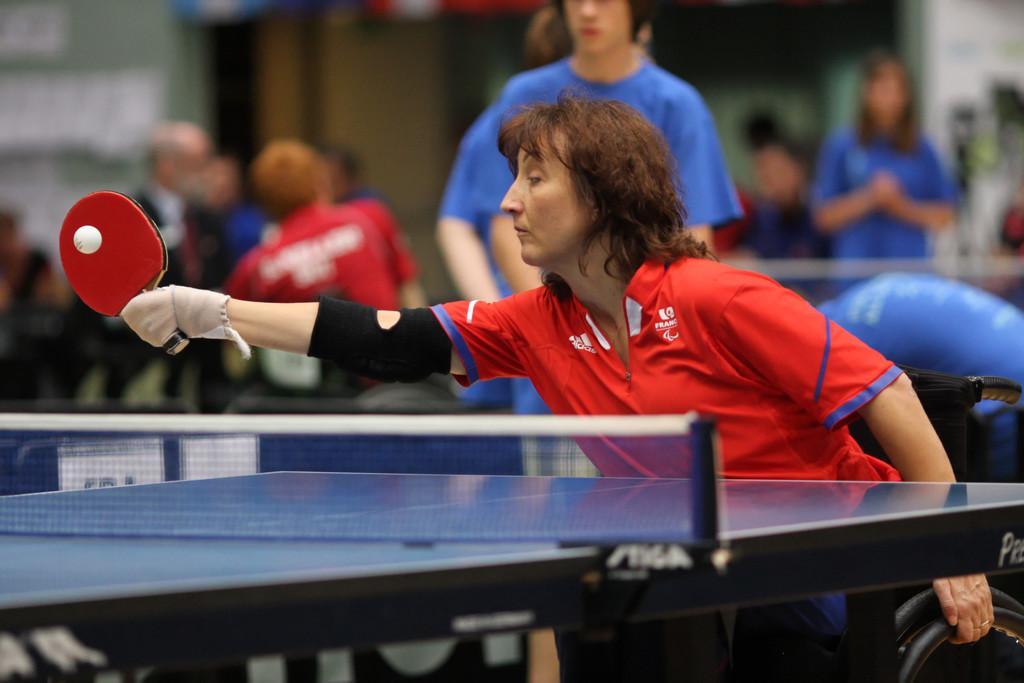In one or two sentences, can you explain what this image depicts? In the image few people are standing and few people are playing table tennis. 